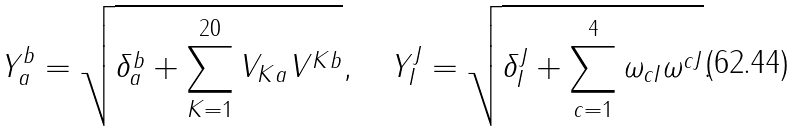Convert formula to latex. <formula><loc_0><loc_0><loc_500><loc_500>Y _ { a } ^ { b } = \sqrt { \delta _ { a } ^ { b } + \sum _ { K = 1 } ^ { 2 0 } V _ { K a } V ^ { K b } } , \quad Y _ { I } ^ { J } = \sqrt { \delta _ { I } ^ { J } + \sum _ { c = 1 } ^ { 4 } \omega _ { c I } \omega ^ { c J } } .</formula> 